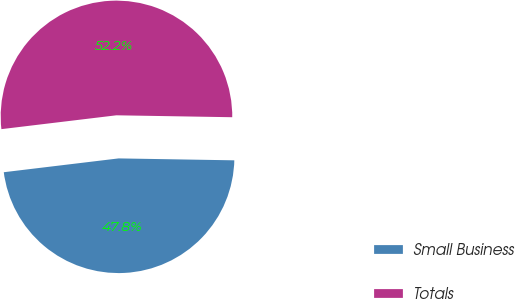<chart> <loc_0><loc_0><loc_500><loc_500><pie_chart><fcel>Small Business<fcel>Totals<nl><fcel>47.83%<fcel>52.17%<nl></chart> 